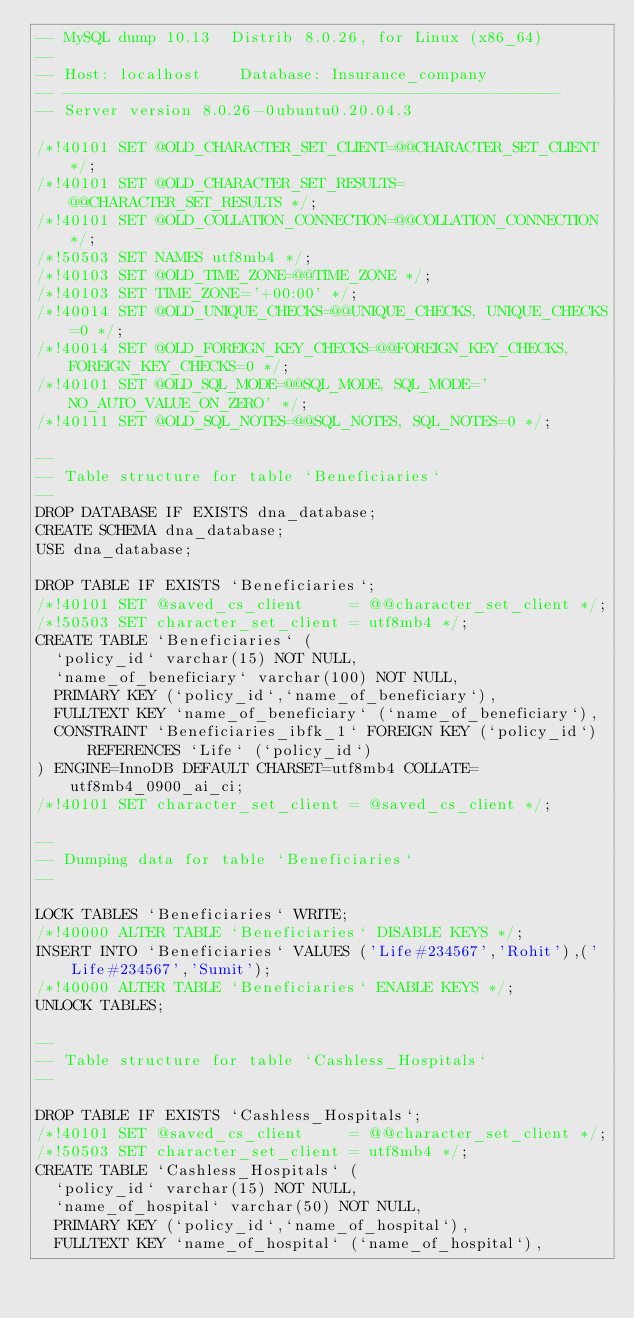<code> <loc_0><loc_0><loc_500><loc_500><_SQL_>-- MySQL dump 10.13  Distrib 8.0.26, for Linux (x86_64)
--
-- Host: localhost    Database: Insurance_company
-- ------------------------------------------------------
-- Server version	8.0.26-0ubuntu0.20.04.3

/*!40101 SET @OLD_CHARACTER_SET_CLIENT=@@CHARACTER_SET_CLIENT */;
/*!40101 SET @OLD_CHARACTER_SET_RESULTS=@@CHARACTER_SET_RESULTS */;
/*!40101 SET @OLD_COLLATION_CONNECTION=@@COLLATION_CONNECTION */;
/*!50503 SET NAMES utf8mb4 */;
/*!40103 SET @OLD_TIME_ZONE=@@TIME_ZONE */;
/*!40103 SET TIME_ZONE='+00:00' */;
/*!40014 SET @OLD_UNIQUE_CHECKS=@@UNIQUE_CHECKS, UNIQUE_CHECKS=0 */;
/*!40014 SET @OLD_FOREIGN_KEY_CHECKS=@@FOREIGN_KEY_CHECKS, FOREIGN_KEY_CHECKS=0 */;
/*!40101 SET @OLD_SQL_MODE=@@SQL_MODE, SQL_MODE='NO_AUTO_VALUE_ON_ZERO' */;
/*!40111 SET @OLD_SQL_NOTES=@@SQL_NOTES, SQL_NOTES=0 */;

--
-- Table structure for table `Beneficiaries`
--
DROP DATABASE IF EXISTS dna_database;
CREATE SCHEMA dna_database;
USE dna_database;

DROP TABLE IF EXISTS `Beneficiaries`;
/*!40101 SET @saved_cs_client     = @@character_set_client */;
/*!50503 SET character_set_client = utf8mb4 */;
CREATE TABLE `Beneficiaries` (
  `policy_id` varchar(15) NOT NULL,
  `name_of_beneficiary` varchar(100) NOT NULL,
  PRIMARY KEY (`policy_id`,`name_of_beneficiary`),
  FULLTEXT KEY `name_of_beneficiary` (`name_of_beneficiary`),
  CONSTRAINT `Beneficiaries_ibfk_1` FOREIGN KEY (`policy_id`) REFERENCES `Life` (`policy_id`)
) ENGINE=InnoDB DEFAULT CHARSET=utf8mb4 COLLATE=utf8mb4_0900_ai_ci;
/*!40101 SET character_set_client = @saved_cs_client */;

--
-- Dumping data for table `Beneficiaries`
--

LOCK TABLES `Beneficiaries` WRITE;
/*!40000 ALTER TABLE `Beneficiaries` DISABLE KEYS */;
INSERT INTO `Beneficiaries` VALUES ('Life#234567','Rohit'),('Life#234567','Sumit');
/*!40000 ALTER TABLE `Beneficiaries` ENABLE KEYS */;
UNLOCK TABLES;

--
-- Table structure for table `Cashless_Hospitals`
--

DROP TABLE IF EXISTS `Cashless_Hospitals`;
/*!40101 SET @saved_cs_client     = @@character_set_client */;
/*!50503 SET character_set_client = utf8mb4 */;
CREATE TABLE `Cashless_Hospitals` (
  `policy_id` varchar(15) NOT NULL,
  `name_of_hospital` varchar(50) NOT NULL,
  PRIMARY KEY (`policy_id`,`name_of_hospital`),
  FULLTEXT KEY `name_of_hospital` (`name_of_hospital`),</code> 